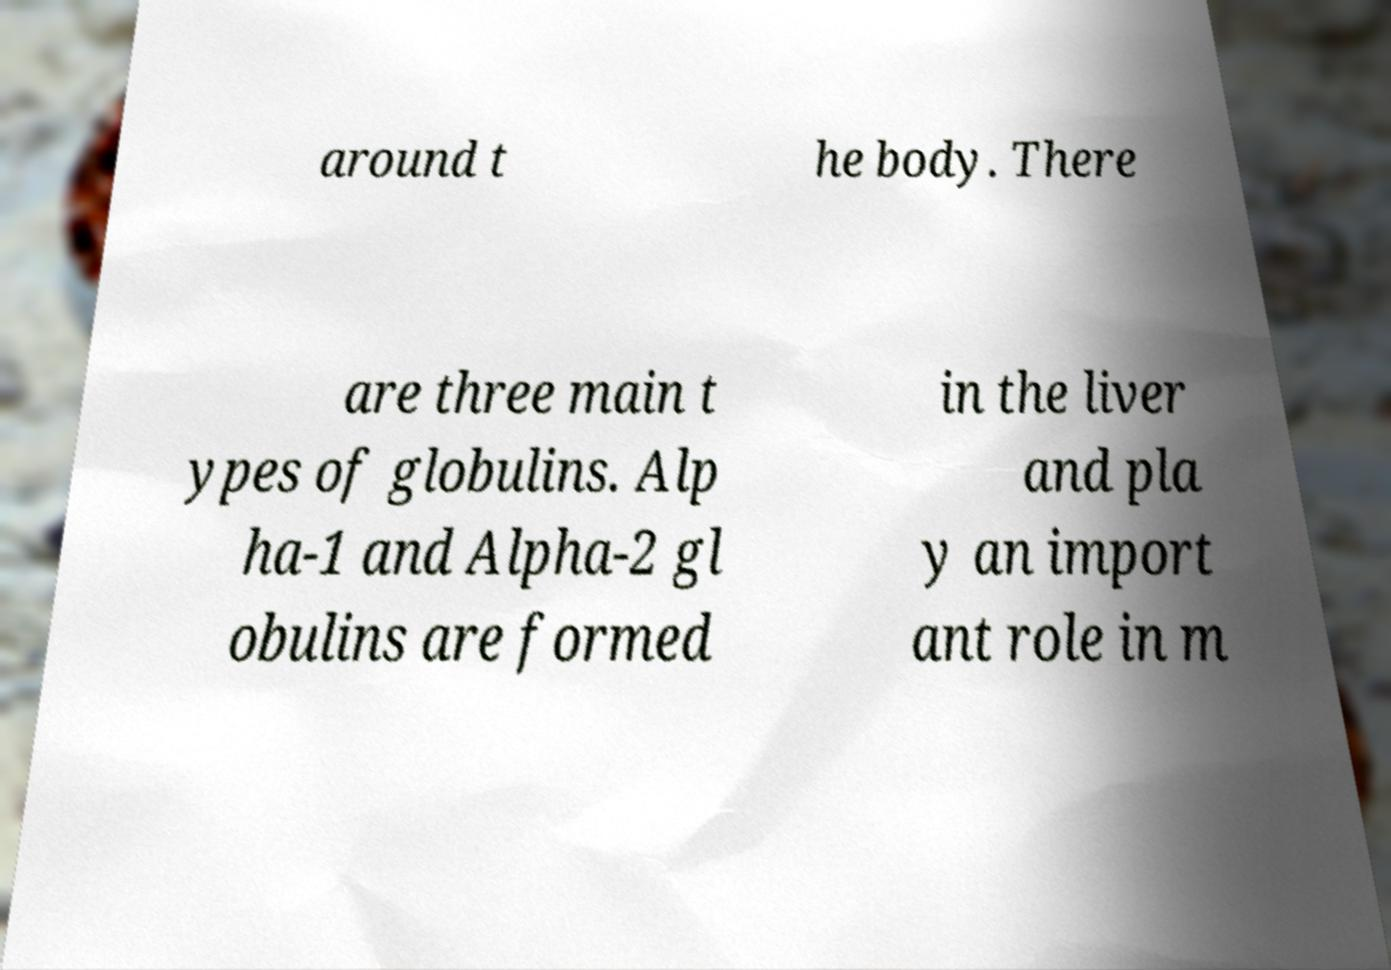Can you accurately transcribe the text from the provided image for me? around t he body. There are three main t ypes of globulins. Alp ha-1 and Alpha-2 gl obulins are formed in the liver and pla y an import ant role in m 